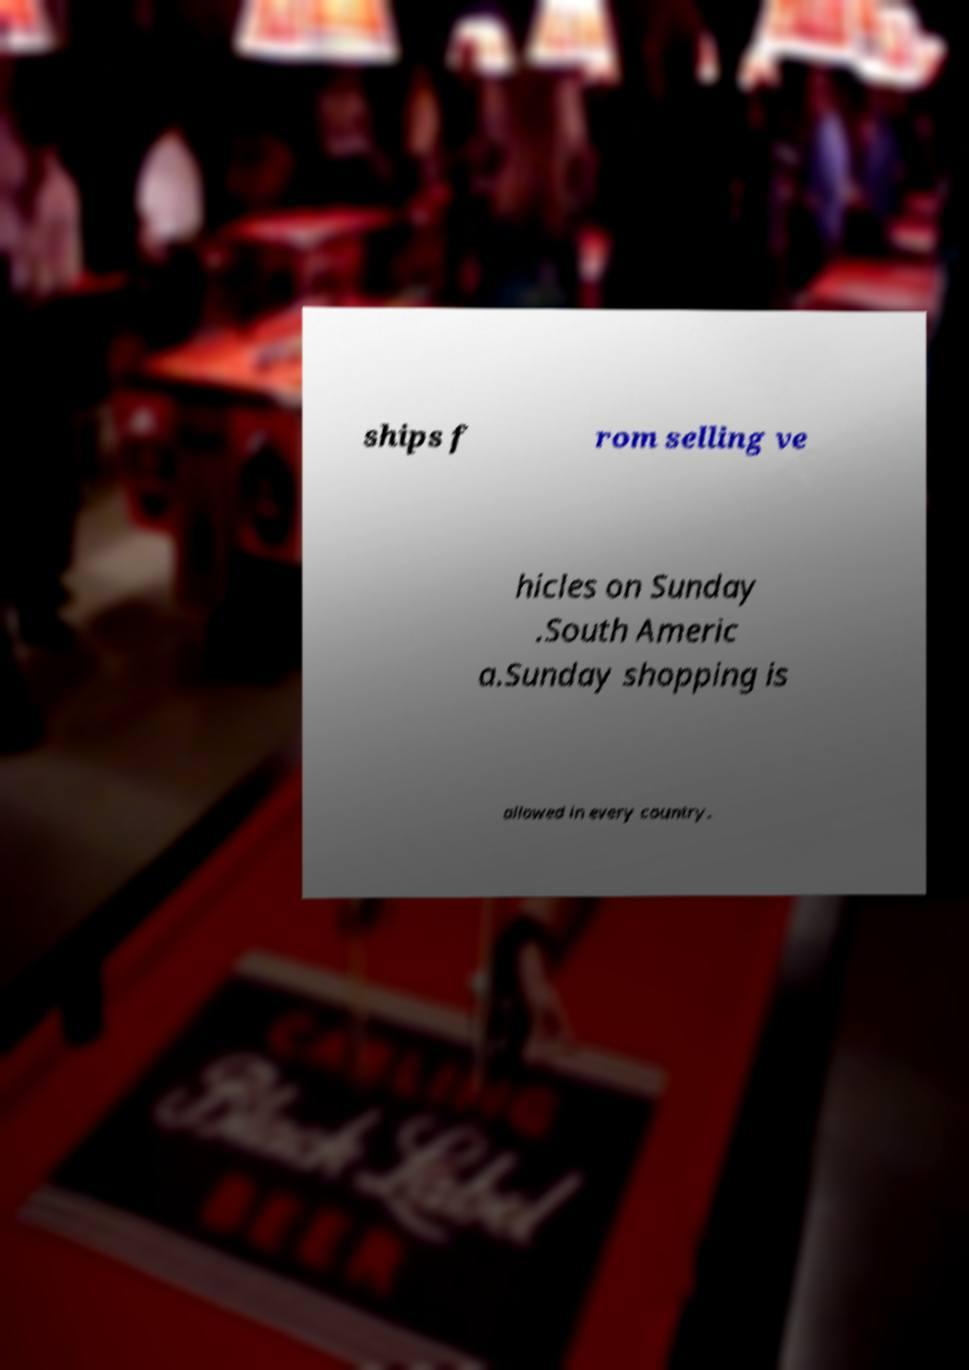I need the written content from this picture converted into text. Can you do that? ships f rom selling ve hicles on Sunday .South Americ a.Sunday shopping is allowed in every country. 